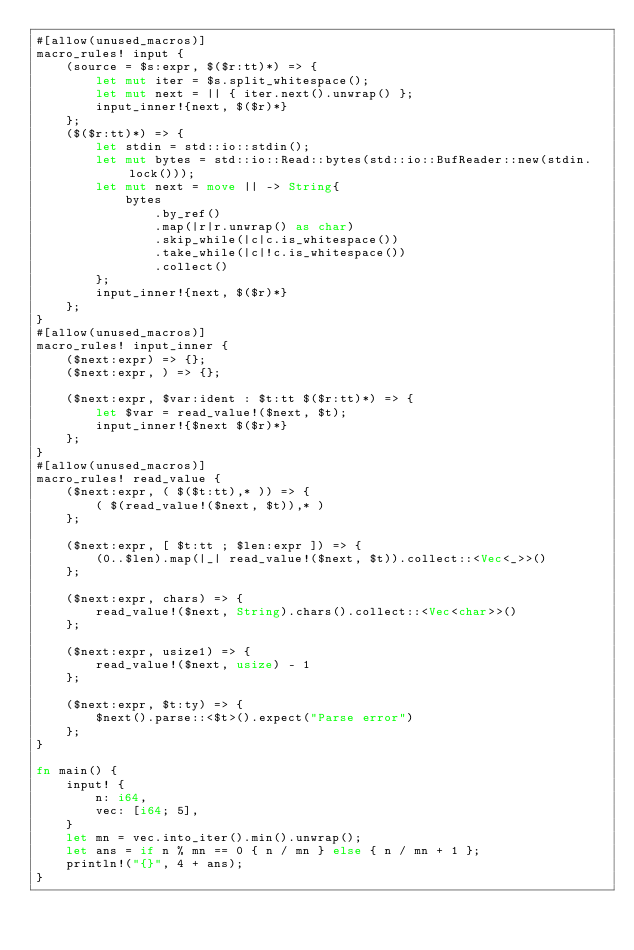<code> <loc_0><loc_0><loc_500><loc_500><_Rust_>#[allow(unused_macros)]
macro_rules! input {
    (source = $s:expr, $($r:tt)*) => {
        let mut iter = $s.split_whitespace();
        let mut next = || { iter.next().unwrap() };
        input_inner!{next, $($r)*}
    };
    ($($r:tt)*) => {
        let stdin = std::io::stdin();
        let mut bytes = std::io::Read::bytes(std::io::BufReader::new(stdin.lock()));
        let mut next = move || -> String{
            bytes
                .by_ref()
                .map(|r|r.unwrap() as char)
                .skip_while(|c|c.is_whitespace())
                .take_while(|c|!c.is_whitespace())
                .collect()
        };
        input_inner!{next, $($r)*}
    };
}
#[allow(unused_macros)]
macro_rules! input_inner {
    ($next:expr) => {};
    ($next:expr, ) => {};

    ($next:expr, $var:ident : $t:tt $($r:tt)*) => {
        let $var = read_value!($next, $t);
        input_inner!{$next $($r)*}
    };
}
#[allow(unused_macros)]
macro_rules! read_value {
    ($next:expr, ( $($t:tt),* )) => {
        ( $(read_value!($next, $t)),* )
    };

    ($next:expr, [ $t:tt ; $len:expr ]) => {
        (0..$len).map(|_| read_value!($next, $t)).collect::<Vec<_>>()
    };

    ($next:expr, chars) => {
        read_value!($next, String).chars().collect::<Vec<char>>()
    };

    ($next:expr, usize1) => {
        read_value!($next, usize) - 1
    };

    ($next:expr, $t:ty) => {
        $next().parse::<$t>().expect("Parse error")
    };
}

fn main() {
    input! {
        n: i64,
        vec: [i64; 5],
    }
    let mn = vec.into_iter().min().unwrap();
    let ans = if n % mn == 0 { n / mn } else { n / mn + 1 };
    println!("{}", 4 + ans);
}
</code> 